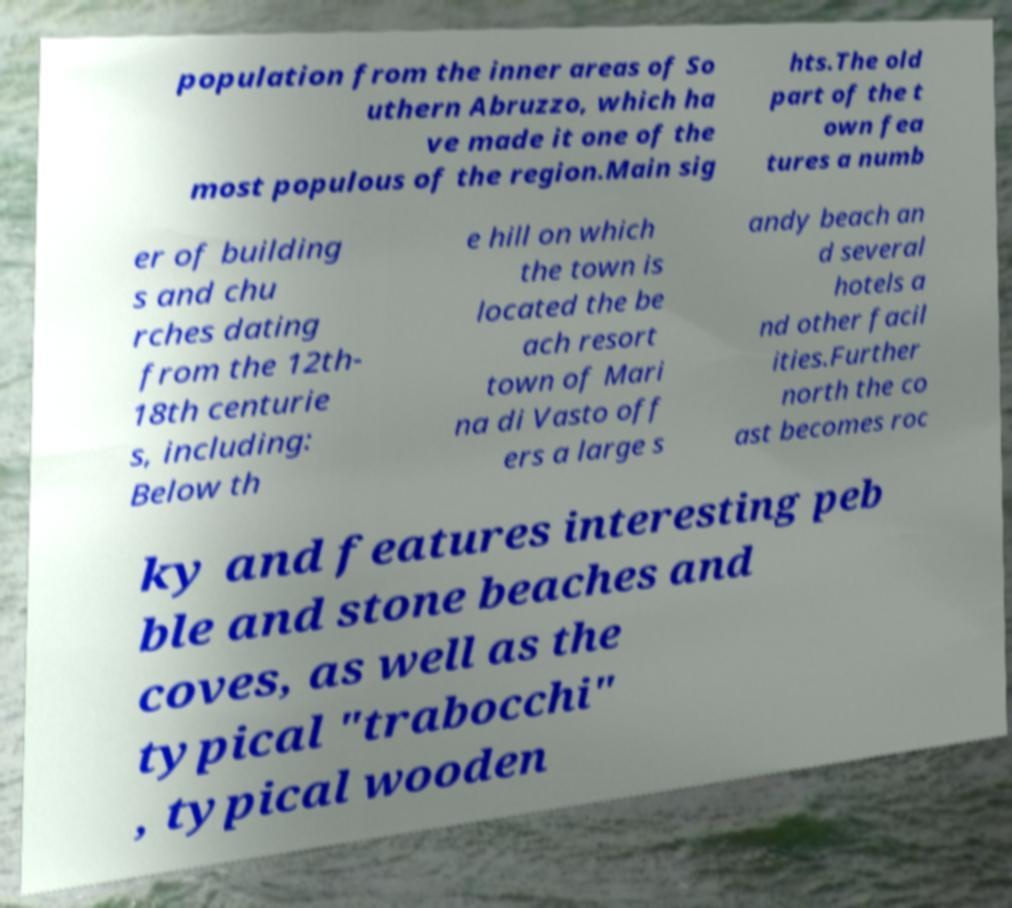There's text embedded in this image that I need extracted. Can you transcribe it verbatim? population from the inner areas of So uthern Abruzzo, which ha ve made it one of the most populous of the region.Main sig hts.The old part of the t own fea tures a numb er of building s and chu rches dating from the 12th- 18th centurie s, including: Below th e hill on which the town is located the be ach resort town of Mari na di Vasto off ers a large s andy beach an d several hotels a nd other facil ities.Further north the co ast becomes roc ky and features interesting peb ble and stone beaches and coves, as well as the typical "trabocchi" , typical wooden 